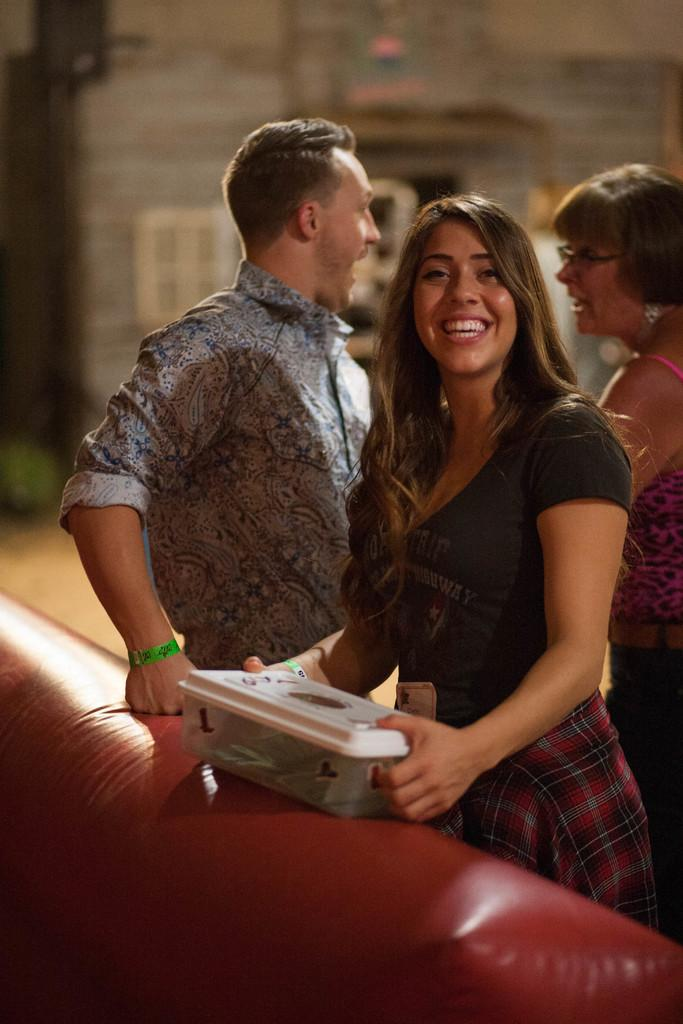What is the gender of the person on the right side of the image? There is a beautiful woman on the right side of the image. What is the woman doing in the image? The woman is standing and smiling. What is the woman wearing in the image? The woman is wearing a dress. Who else is present in the image? There is a man in the image. Where is the man located in the image? The man is in the middle of the image. What is the man wearing in the image? The man is wearing a shirt. What type of bead is the woman holding in the image? There is no bead present in the image. Is the man holding a rifle in the image? No, the man is not holding a rifle in the image. Can you see the sea in the background of the image? No, there is no sea visible in the image. 